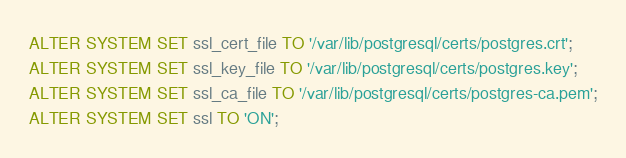<code> <loc_0><loc_0><loc_500><loc_500><_SQL_>ALTER SYSTEM SET ssl_cert_file TO '/var/lib/postgresql/certs/postgres.crt';
ALTER SYSTEM SET ssl_key_file TO '/var/lib/postgresql/certs/postgres.key';
ALTER SYSTEM SET ssl_ca_file TO '/var/lib/postgresql/certs/postgres-ca.pem';
ALTER SYSTEM SET ssl TO 'ON';
</code> 